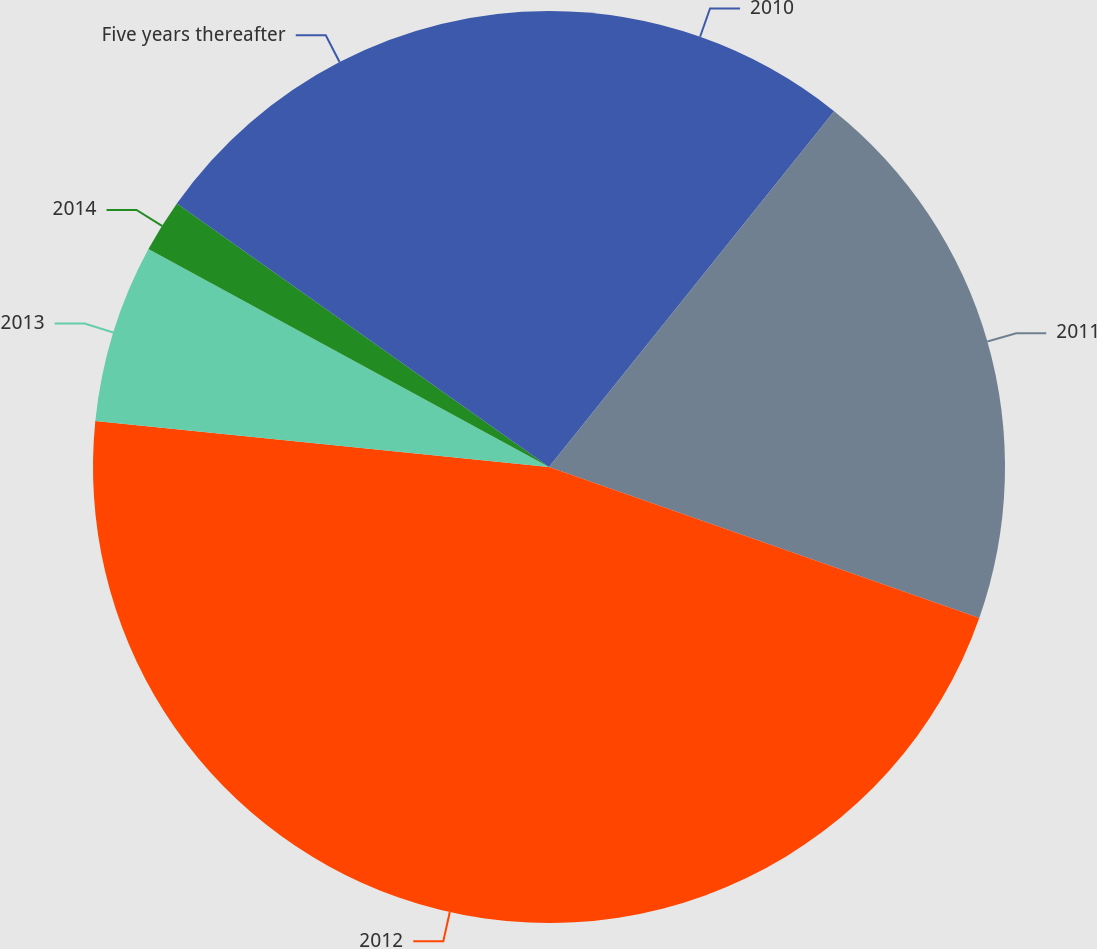Convert chart. <chart><loc_0><loc_0><loc_500><loc_500><pie_chart><fcel>2010<fcel>2011<fcel>2012<fcel>2013<fcel>2014<fcel>Five years thereafter<nl><fcel>10.75%<fcel>19.62%<fcel>46.23%<fcel>6.32%<fcel>1.88%<fcel>15.19%<nl></chart> 